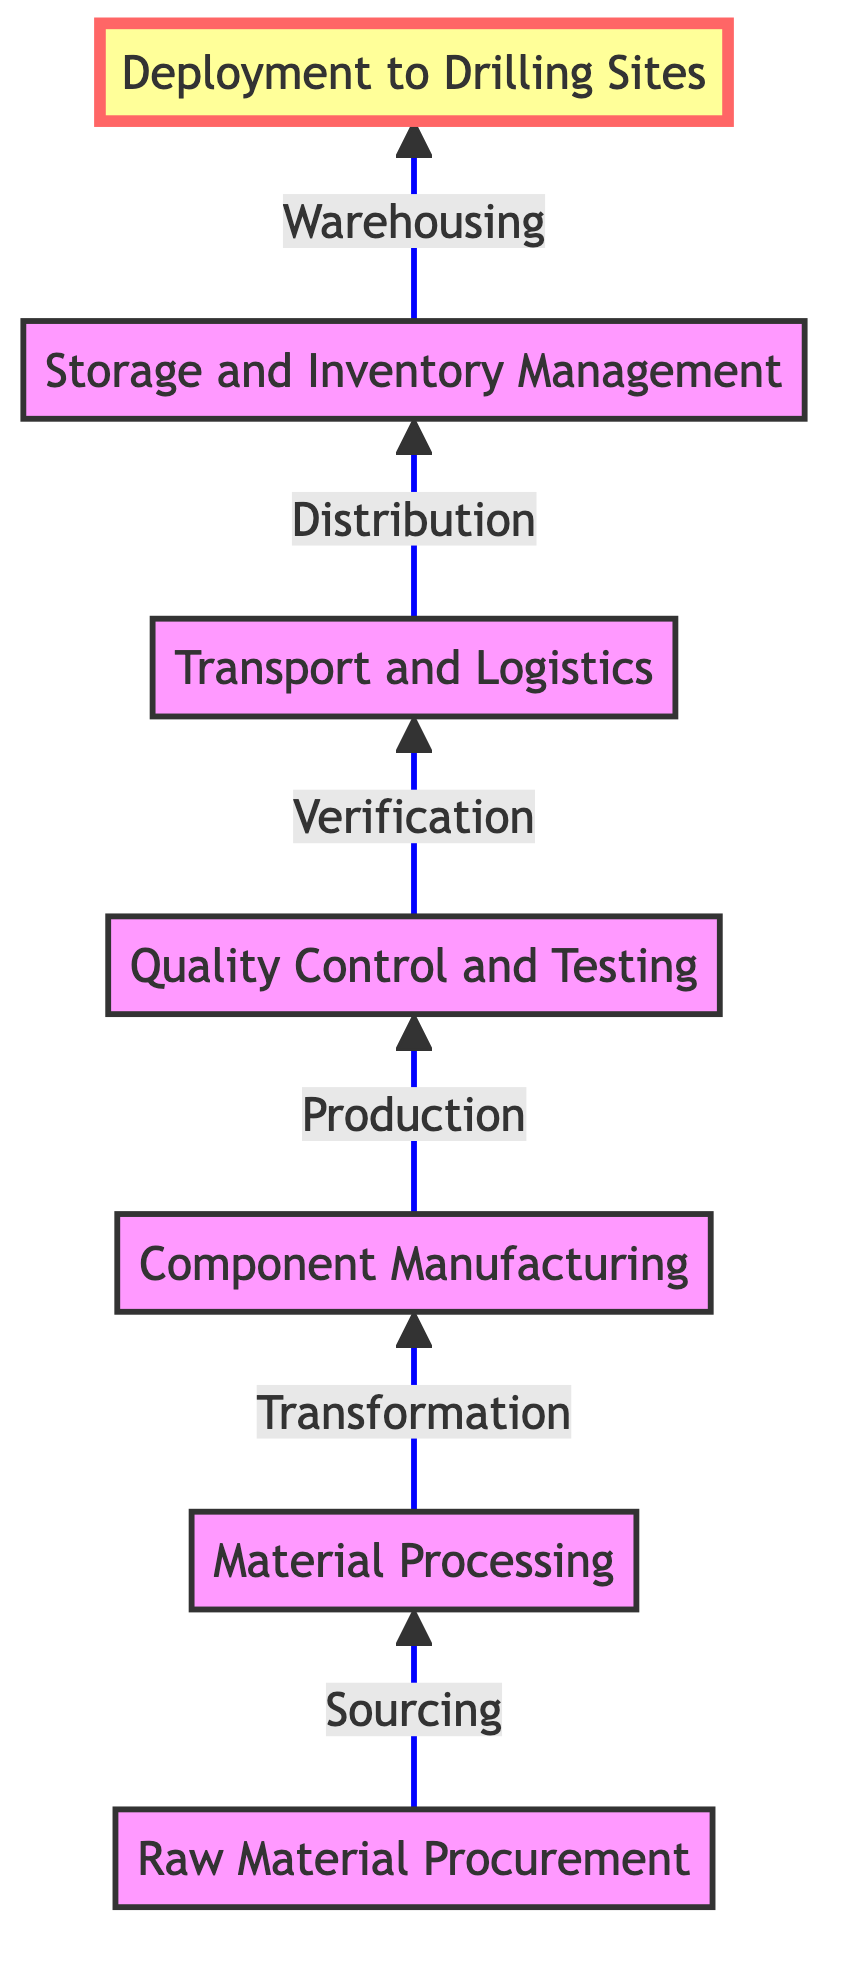What is the first step in the supply chain? The first step in the flow chart is "Raw Material Procurement," which is the starting point for sourcing essential raw materials.
Answer: Raw Material Procurement How many nodes are there in the diagram? By counting all the unique elements listed, we can see there are seven nodes representing different stages of the supply chain.
Answer: Seven Which step comes after component manufacturing? The next step in the flow chart, after "Component Manufacturing," is "Quality Control and Testing." This follows the logical sequence of ensuring components meet industry standards.
Answer: Quality Control and Testing What is the final destination of the process depicted in the diagram? The final destination in the flow chart is "Deployment to Drilling Sites," which signifies the end of the supply chain process with equipment being set up at drilling locations.
Answer: Deployment to Drilling Sites What is the connection between Transport and Logistics and Storage and Inventory Management? "Transport and Logistics" leads to "Storage and Inventory Management," indicating that after distribution, the equipment is managed in storage until needed.
Answer: Storage and Inventory Management What type of companies handle Deployment to Drilling Sites? The step "Deployment to Drilling Sites" mentions that specialized drilling contractors execute this phase, highlighting their expertise in setting up equipment at sites.
Answer: Specialized drilling contractors What guarantees the quality of components before deployment? "Quality Control and Testing" is the step ensuring the verification and reliability of components through rigorous testing before they are shipped or deployed.
Answer: Quality Control and Testing 